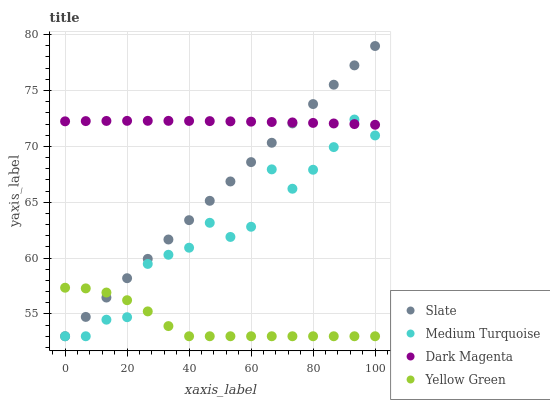Does Yellow Green have the minimum area under the curve?
Answer yes or no. Yes. Does Dark Magenta have the maximum area under the curve?
Answer yes or no. Yes. Does Medium Turquoise have the minimum area under the curve?
Answer yes or no. No. Does Medium Turquoise have the maximum area under the curve?
Answer yes or no. No. Is Slate the smoothest?
Answer yes or no. Yes. Is Medium Turquoise the roughest?
Answer yes or no. Yes. Is Dark Magenta the smoothest?
Answer yes or no. No. Is Dark Magenta the roughest?
Answer yes or no. No. Does Slate have the lowest value?
Answer yes or no. Yes. Does Dark Magenta have the lowest value?
Answer yes or no. No. Does Slate have the highest value?
Answer yes or no. Yes. Does Dark Magenta have the highest value?
Answer yes or no. No. Is Yellow Green less than Dark Magenta?
Answer yes or no. Yes. Is Dark Magenta greater than Yellow Green?
Answer yes or no. Yes. Does Dark Magenta intersect Slate?
Answer yes or no. Yes. Is Dark Magenta less than Slate?
Answer yes or no. No. Is Dark Magenta greater than Slate?
Answer yes or no. No. Does Yellow Green intersect Dark Magenta?
Answer yes or no. No. 